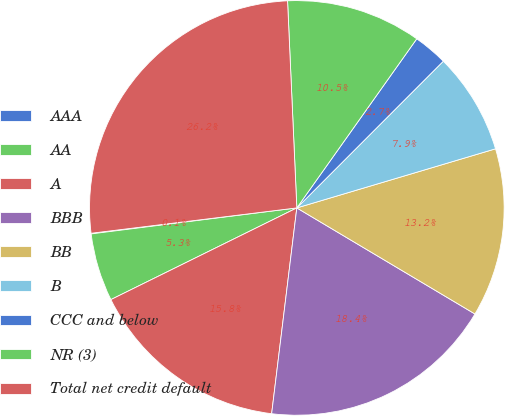Convert chart. <chart><loc_0><loc_0><loc_500><loc_500><pie_chart><fcel>AAA<fcel>AA<fcel>A<fcel>BBB<fcel>BB<fcel>B<fcel>CCC and below<fcel>NR (3)<fcel>Total net credit default<nl><fcel>0.05%<fcel>5.29%<fcel>15.77%<fcel>18.39%<fcel>13.15%<fcel>7.91%<fcel>2.67%<fcel>10.53%<fcel>26.24%<nl></chart> 